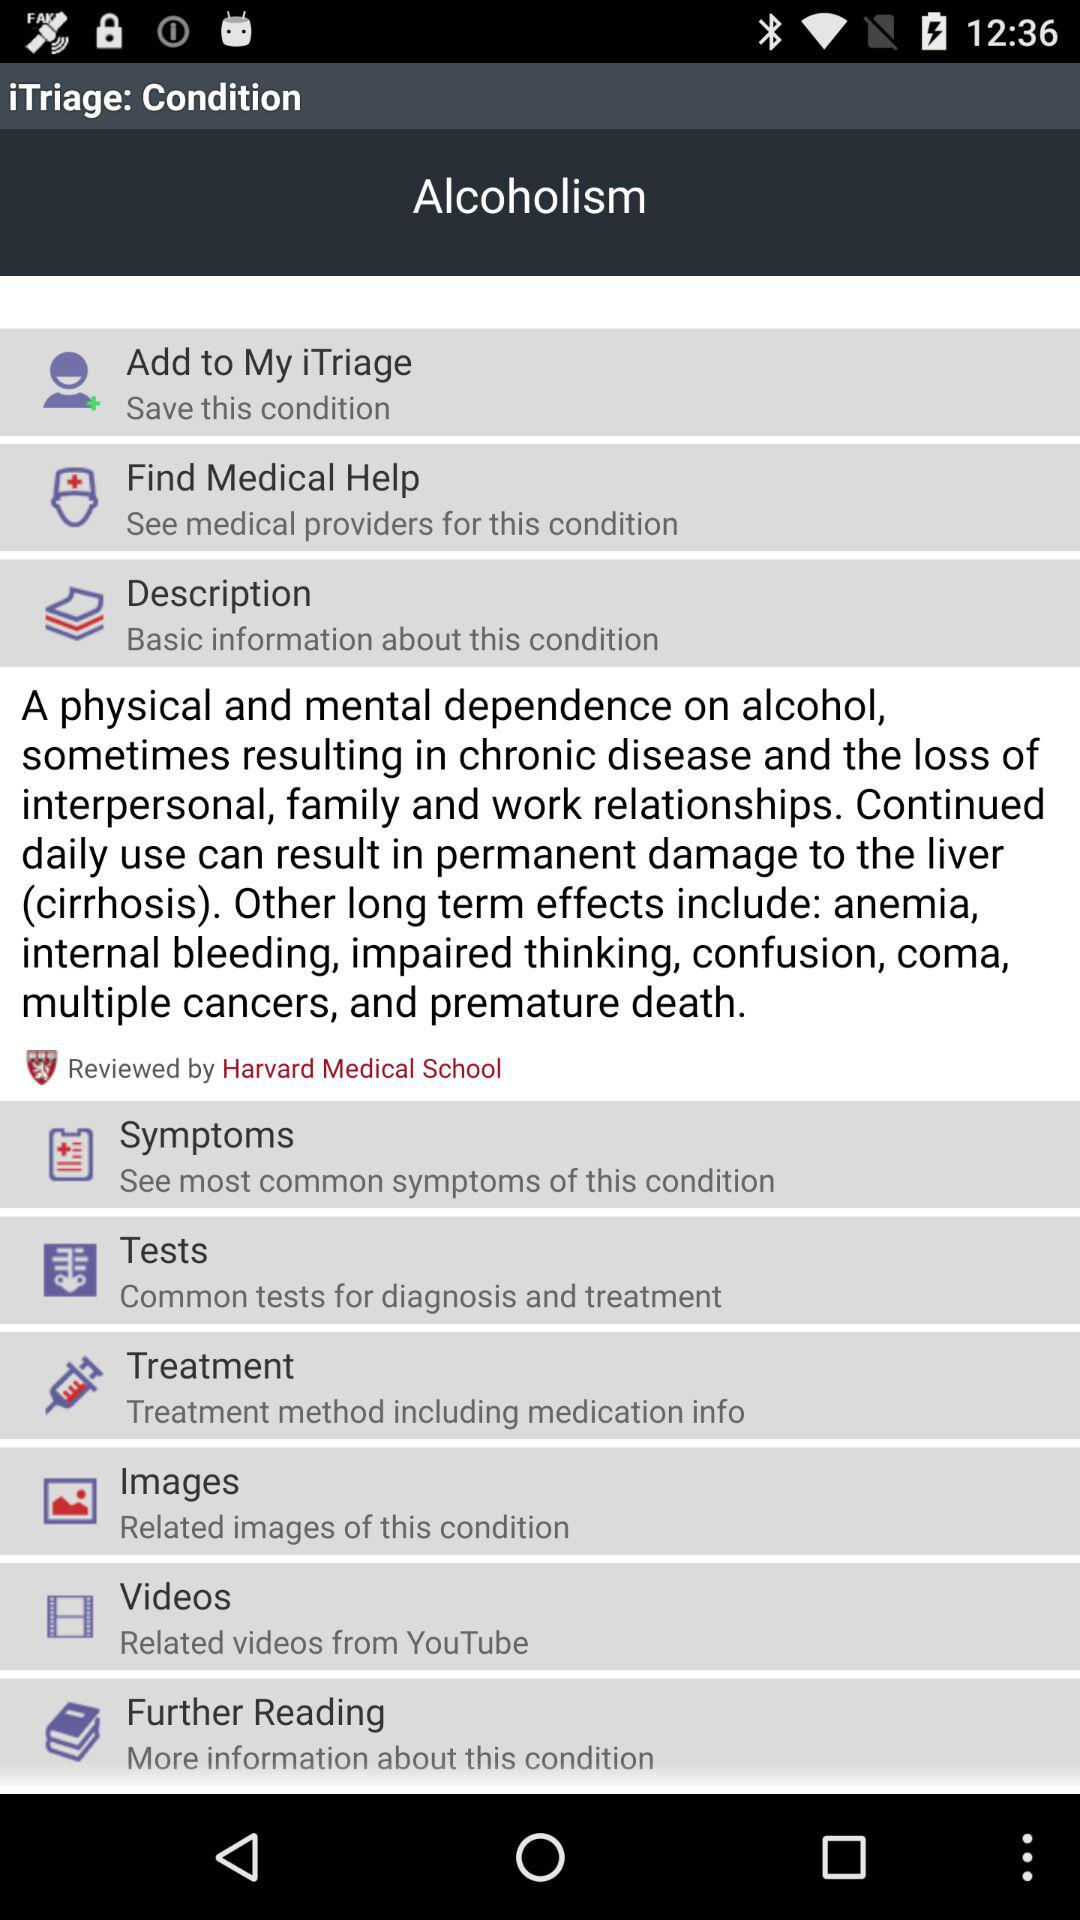By whom was the description reviewed? The description was reviewed by Harvard Medical School. 